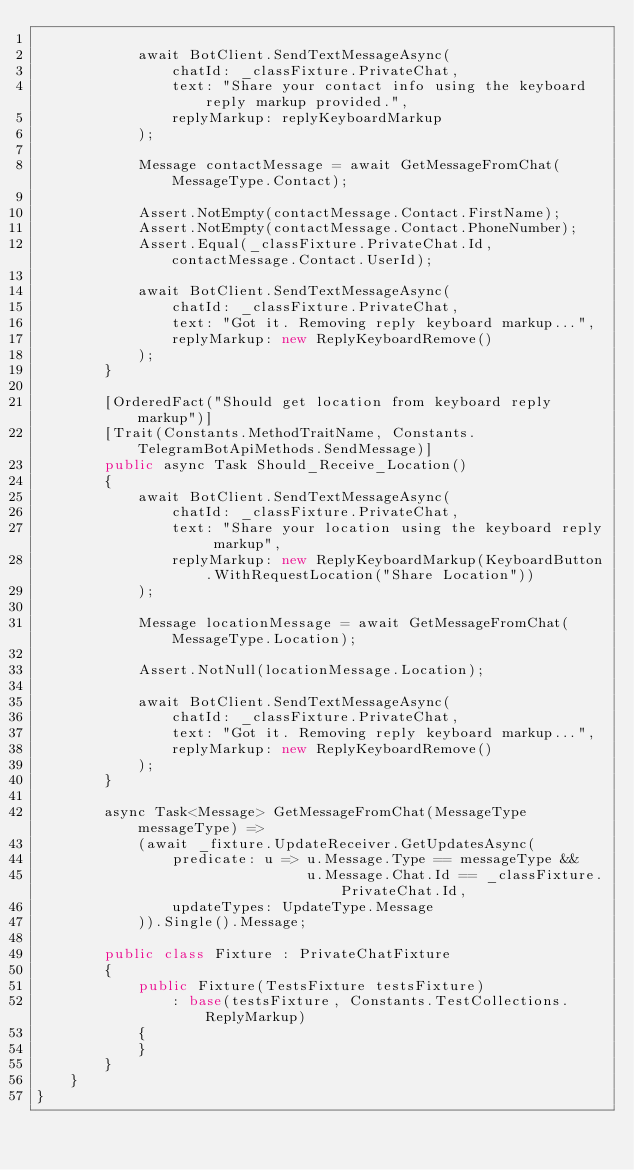Convert code to text. <code><loc_0><loc_0><loc_500><loc_500><_C#_>
            await BotClient.SendTextMessageAsync(
                chatId: _classFixture.PrivateChat,
                text: "Share your contact info using the keyboard reply markup provided.",
                replyMarkup: replyKeyboardMarkup
            );

            Message contactMessage = await GetMessageFromChat(MessageType.Contact);

            Assert.NotEmpty(contactMessage.Contact.FirstName);
            Assert.NotEmpty(contactMessage.Contact.PhoneNumber);
            Assert.Equal(_classFixture.PrivateChat.Id, contactMessage.Contact.UserId);

            await BotClient.SendTextMessageAsync(
                chatId: _classFixture.PrivateChat,
                text: "Got it. Removing reply keyboard markup...",
                replyMarkup: new ReplyKeyboardRemove()
            );
        }

        [OrderedFact("Should get location from keyboard reply markup")]
        [Trait(Constants.MethodTraitName, Constants.TelegramBotApiMethods.SendMessage)]
        public async Task Should_Receive_Location()
        {
            await BotClient.SendTextMessageAsync(
                chatId: _classFixture.PrivateChat,
                text: "Share your location using the keyboard reply markup",
                replyMarkup: new ReplyKeyboardMarkup(KeyboardButton.WithRequestLocation("Share Location"))
            );

            Message locationMessage = await GetMessageFromChat(MessageType.Location);

            Assert.NotNull(locationMessage.Location);

            await BotClient.SendTextMessageAsync(
                chatId: _classFixture.PrivateChat,
                text: "Got it. Removing reply keyboard markup...",
                replyMarkup: new ReplyKeyboardRemove()
            );
        }

        async Task<Message> GetMessageFromChat(MessageType messageType) =>
            (await _fixture.UpdateReceiver.GetUpdatesAsync(
                predicate: u => u.Message.Type == messageType &&
                                u.Message.Chat.Id == _classFixture.PrivateChat.Id,
                updateTypes: UpdateType.Message
            )).Single().Message;

        public class Fixture : PrivateChatFixture
        {
            public Fixture(TestsFixture testsFixture)
                : base(testsFixture, Constants.TestCollections.ReplyMarkup)
            {
            }
        }
    }
}
</code> 